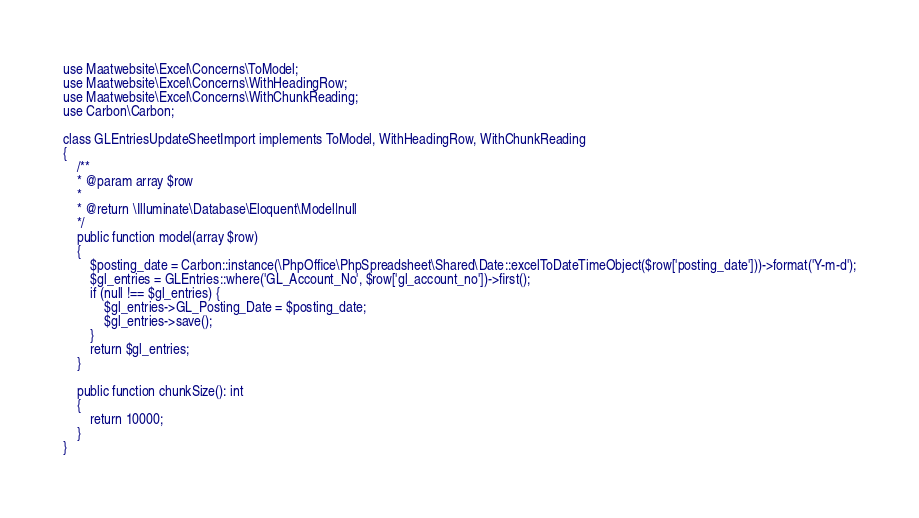Convert code to text. <code><loc_0><loc_0><loc_500><loc_500><_PHP_>use Maatwebsite\Excel\Concerns\ToModel;
use Maatwebsite\Excel\Concerns\WithHeadingRow;
use Maatwebsite\Excel\Concerns\WithChunkReading;
use Carbon\Carbon;

class GLEntriesUpdateSheetImport implements ToModel, WithHeadingRow, WithChunkReading
{
    /**
    * @param array $row
    *
    * @return \Illuminate\Database\Eloquent\Model|null
    */
    public function model(array $row)
    {
    	$posting_date = Carbon::instance(\PhpOffice\PhpSpreadsheet\Shared\Date::excelToDateTimeObject($row['posting_date']))->format('Y-m-d');
    	$gl_entries = GLEntries::where('GL_Account_No', $row['gl_account_no'])->first();
    	if (null !== $gl_entries) {
    		$gl_entries->GL_Posting_Date = $posting_date;
	    	$gl_entries->save();
    	}
	    return $gl_entries;
    }

    public function chunkSize(): int
    {
        return 10000;
    }
}</code> 